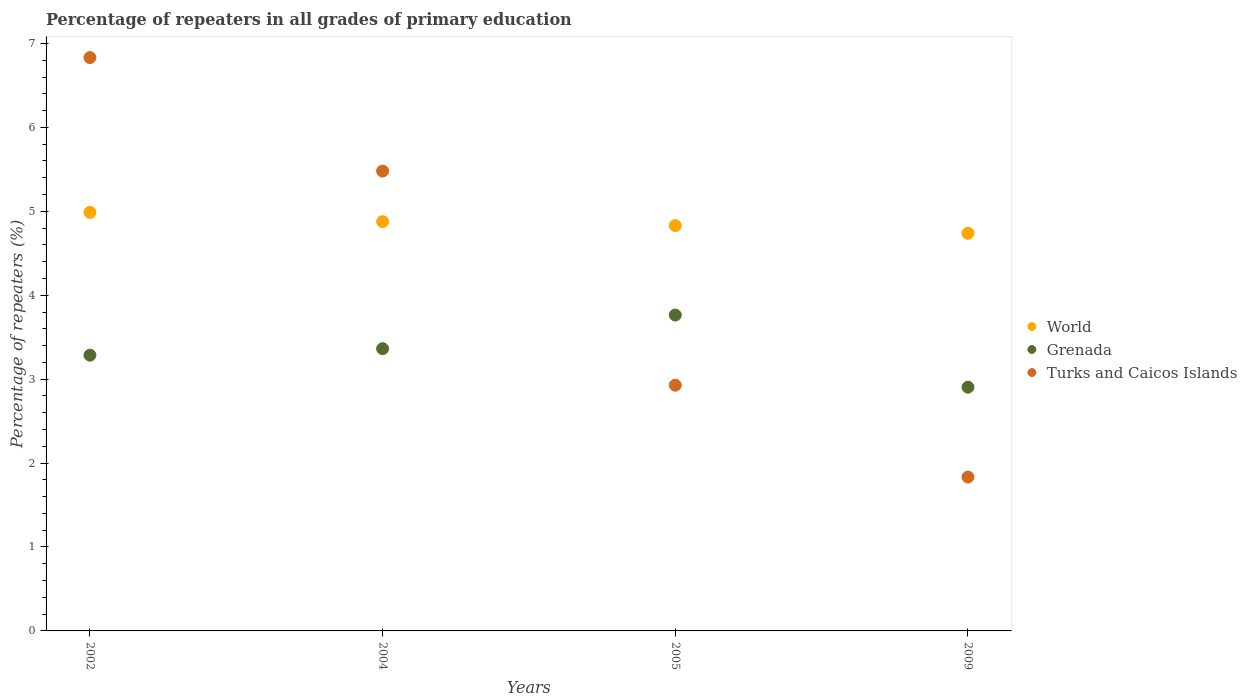What is the percentage of repeaters in World in 2002?
Offer a terse response. 4.99. Across all years, what is the maximum percentage of repeaters in World?
Keep it short and to the point. 4.99. Across all years, what is the minimum percentage of repeaters in World?
Provide a succinct answer. 4.74. In which year was the percentage of repeaters in World minimum?
Keep it short and to the point. 2009. What is the total percentage of repeaters in World in the graph?
Provide a short and direct response. 19.43. What is the difference between the percentage of repeaters in Grenada in 2002 and that in 2009?
Ensure brevity in your answer.  0.38. What is the difference between the percentage of repeaters in Turks and Caicos Islands in 2004 and the percentage of repeaters in World in 2005?
Provide a succinct answer. 0.65. What is the average percentage of repeaters in Turks and Caicos Islands per year?
Your response must be concise. 4.27. In the year 2009, what is the difference between the percentage of repeaters in Turks and Caicos Islands and percentage of repeaters in Grenada?
Provide a short and direct response. -1.07. What is the ratio of the percentage of repeaters in Turks and Caicos Islands in 2002 to that in 2009?
Provide a succinct answer. 3.73. What is the difference between the highest and the second highest percentage of repeaters in Turks and Caicos Islands?
Provide a short and direct response. 1.35. What is the difference between the highest and the lowest percentage of repeaters in Grenada?
Provide a short and direct response. 0.86. In how many years, is the percentage of repeaters in Turks and Caicos Islands greater than the average percentage of repeaters in Turks and Caicos Islands taken over all years?
Keep it short and to the point. 2. Is it the case that in every year, the sum of the percentage of repeaters in World and percentage of repeaters in Turks and Caicos Islands  is greater than the percentage of repeaters in Grenada?
Offer a very short reply. Yes. Does the percentage of repeaters in Turks and Caicos Islands monotonically increase over the years?
Ensure brevity in your answer.  No. Is the percentage of repeaters in Turks and Caicos Islands strictly less than the percentage of repeaters in World over the years?
Give a very brief answer. No. How many dotlines are there?
Your answer should be compact. 3. How many years are there in the graph?
Your answer should be compact. 4. Does the graph contain grids?
Make the answer very short. No. Where does the legend appear in the graph?
Your answer should be very brief. Center right. How are the legend labels stacked?
Offer a very short reply. Vertical. What is the title of the graph?
Provide a short and direct response. Percentage of repeaters in all grades of primary education. What is the label or title of the X-axis?
Provide a succinct answer. Years. What is the label or title of the Y-axis?
Ensure brevity in your answer.  Percentage of repeaters (%). What is the Percentage of repeaters (%) of World in 2002?
Provide a succinct answer. 4.99. What is the Percentage of repeaters (%) in Grenada in 2002?
Ensure brevity in your answer.  3.29. What is the Percentage of repeaters (%) of Turks and Caicos Islands in 2002?
Provide a short and direct response. 6.83. What is the Percentage of repeaters (%) of World in 2004?
Make the answer very short. 4.88. What is the Percentage of repeaters (%) in Grenada in 2004?
Provide a succinct answer. 3.36. What is the Percentage of repeaters (%) of Turks and Caicos Islands in 2004?
Offer a very short reply. 5.48. What is the Percentage of repeaters (%) in World in 2005?
Offer a very short reply. 4.83. What is the Percentage of repeaters (%) of Grenada in 2005?
Your answer should be very brief. 3.76. What is the Percentage of repeaters (%) in Turks and Caicos Islands in 2005?
Ensure brevity in your answer.  2.93. What is the Percentage of repeaters (%) in World in 2009?
Your answer should be compact. 4.74. What is the Percentage of repeaters (%) in Grenada in 2009?
Offer a very short reply. 2.9. What is the Percentage of repeaters (%) in Turks and Caicos Islands in 2009?
Your answer should be very brief. 1.83. Across all years, what is the maximum Percentage of repeaters (%) of World?
Give a very brief answer. 4.99. Across all years, what is the maximum Percentage of repeaters (%) in Grenada?
Make the answer very short. 3.76. Across all years, what is the maximum Percentage of repeaters (%) in Turks and Caicos Islands?
Your answer should be very brief. 6.83. Across all years, what is the minimum Percentage of repeaters (%) in World?
Your response must be concise. 4.74. Across all years, what is the minimum Percentage of repeaters (%) in Grenada?
Your answer should be compact. 2.9. Across all years, what is the minimum Percentage of repeaters (%) in Turks and Caicos Islands?
Offer a very short reply. 1.83. What is the total Percentage of repeaters (%) in World in the graph?
Your answer should be compact. 19.43. What is the total Percentage of repeaters (%) of Grenada in the graph?
Keep it short and to the point. 13.32. What is the total Percentage of repeaters (%) in Turks and Caicos Islands in the graph?
Provide a succinct answer. 17.07. What is the difference between the Percentage of repeaters (%) in World in 2002 and that in 2004?
Make the answer very short. 0.11. What is the difference between the Percentage of repeaters (%) in Grenada in 2002 and that in 2004?
Provide a succinct answer. -0.08. What is the difference between the Percentage of repeaters (%) of Turks and Caicos Islands in 2002 and that in 2004?
Keep it short and to the point. 1.35. What is the difference between the Percentage of repeaters (%) of World in 2002 and that in 2005?
Offer a very short reply. 0.16. What is the difference between the Percentage of repeaters (%) in Grenada in 2002 and that in 2005?
Your answer should be very brief. -0.48. What is the difference between the Percentage of repeaters (%) in Turks and Caicos Islands in 2002 and that in 2005?
Provide a short and direct response. 3.9. What is the difference between the Percentage of repeaters (%) in World in 2002 and that in 2009?
Your answer should be compact. 0.25. What is the difference between the Percentage of repeaters (%) in Grenada in 2002 and that in 2009?
Offer a very short reply. 0.38. What is the difference between the Percentage of repeaters (%) in Turks and Caicos Islands in 2002 and that in 2009?
Give a very brief answer. 5. What is the difference between the Percentage of repeaters (%) of World in 2004 and that in 2005?
Provide a succinct answer. 0.05. What is the difference between the Percentage of repeaters (%) in Grenada in 2004 and that in 2005?
Give a very brief answer. -0.4. What is the difference between the Percentage of repeaters (%) in Turks and Caicos Islands in 2004 and that in 2005?
Offer a very short reply. 2.55. What is the difference between the Percentage of repeaters (%) of World in 2004 and that in 2009?
Offer a terse response. 0.14. What is the difference between the Percentage of repeaters (%) in Grenada in 2004 and that in 2009?
Your response must be concise. 0.46. What is the difference between the Percentage of repeaters (%) of Turks and Caicos Islands in 2004 and that in 2009?
Provide a short and direct response. 3.65. What is the difference between the Percentage of repeaters (%) of World in 2005 and that in 2009?
Provide a short and direct response. 0.09. What is the difference between the Percentage of repeaters (%) in Grenada in 2005 and that in 2009?
Your answer should be very brief. 0.86. What is the difference between the Percentage of repeaters (%) in Turks and Caicos Islands in 2005 and that in 2009?
Ensure brevity in your answer.  1.09. What is the difference between the Percentage of repeaters (%) in World in 2002 and the Percentage of repeaters (%) in Grenada in 2004?
Provide a succinct answer. 1.62. What is the difference between the Percentage of repeaters (%) in World in 2002 and the Percentage of repeaters (%) in Turks and Caicos Islands in 2004?
Ensure brevity in your answer.  -0.49. What is the difference between the Percentage of repeaters (%) in Grenada in 2002 and the Percentage of repeaters (%) in Turks and Caicos Islands in 2004?
Provide a short and direct response. -2.19. What is the difference between the Percentage of repeaters (%) in World in 2002 and the Percentage of repeaters (%) in Grenada in 2005?
Your answer should be compact. 1.22. What is the difference between the Percentage of repeaters (%) of World in 2002 and the Percentage of repeaters (%) of Turks and Caicos Islands in 2005?
Your answer should be very brief. 2.06. What is the difference between the Percentage of repeaters (%) in Grenada in 2002 and the Percentage of repeaters (%) in Turks and Caicos Islands in 2005?
Your answer should be compact. 0.36. What is the difference between the Percentage of repeaters (%) in World in 2002 and the Percentage of repeaters (%) in Grenada in 2009?
Keep it short and to the point. 2.08. What is the difference between the Percentage of repeaters (%) in World in 2002 and the Percentage of repeaters (%) in Turks and Caicos Islands in 2009?
Give a very brief answer. 3.15. What is the difference between the Percentage of repeaters (%) in Grenada in 2002 and the Percentage of repeaters (%) in Turks and Caicos Islands in 2009?
Your answer should be very brief. 1.45. What is the difference between the Percentage of repeaters (%) of World in 2004 and the Percentage of repeaters (%) of Grenada in 2005?
Your answer should be compact. 1.11. What is the difference between the Percentage of repeaters (%) in World in 2004 and the Percentage of repeaters (%) in Turks and Caicos Islands in 2005?
Provide a succinct answer. 1.95. What is the difference between the Percentage of repeaters (%) in Grenada in 2004 and the Percentage of repeaters (%) in Turks and Caicos Islands in 2005?
Offer a terse response. 0.44. What is the difference between the Percentage of repeaters (%) of World in 2004 and the Percentage of repeaters (%) of Grenada in 2009?
Provide a succinct answer. 1.97. What is the difference between the Percentage of repeaters (%) of World in 2004 and the Percentage of repeaters (%) of Turks and Caicos Islands in 2009?
Offer a very short reply. 3.04. What is the difference between the Percentage of repeaters (%) of Grenada in 2004 and the Percentage of repeaters (%) of Turks and Caicos Islands in 2009?
Provide a succinct answer. 1.53. What is the difference between the Percentage of repeaters (%) in World in 2005 and the Percentage of repeaters (%) in Grenada in 2009?
Give a very brief answer. 1.93. What is the difference between the Percentage of repeaters (%) of World in 2005 and the Percentage of repeaters (%) of Turks and Caicos Islands in 2009?
Make the answer very short. 3. What is the difference between the Percentage of repeaters (%) of Grenada in 2005 and the Percentage of repeaters (%) of Turks and Caicos Islands in 2009?
Your answer should be compact. 1.93. What is the average Percentage of repeaters (%) of World per year?
Offer a terse response. 4.86. What is the average Percentage of repeaters (%) in Grenada per year?
Your response must be concise. 3.33. What is the average Percentage of repeaters (%) in Turks and Caicos Islands per year?
Keep it short and to the point. 4.27. In the year 2002, what is the difference between the Percentage of repeaters (%) in World and Percentage of repeaters (%) in Grenada?
Offer a terse response. 1.7. In the year 2002, what is the difference between the Percentage of repeaters (%) in World and Percentage of repeaters (%) in Turks and Caicos Islands?
Make the answer very short. -1.84. In the year 2002, what is the difference between the Percentage of repeaters (%) in Grenada and Percentage of repeaters (%) in Turks and Caicos Islands?
Your response must be concise. -3.55. In the year 2004, what is the difference between the Percentage of repeaters (%) of World and Percentage of repeaters (%) of Grenada?
Provide a succinct answer. 1.51. In the year 2004, what is the difference between the Percentage of repeaters (%) in World and Percentage of repeaters (%) in Turks and Caicos Islands?
Your response must be concise. -0.6. In the year 2004, what is the difference between the Percentage of repeaters (%) in Grenada and Percentage of repeaters (%) in Turks and Caicos Islands?
Your response must be concise. -2.12. In the year 2005, what is the difference between the Percentage of repeaters (%) in World and Percentage of repeaters (%) in Grenada?
Ensure brevity in your answer.  1.07. In the year 2005, what is the difference between the Percentage of repeaters (%) in World and Percentage of repeaters (%) in Turks and Caicos Islands?
Ensure brevity in your answer.  1.9. In the year 2005, what is the difference between the Percentage of repeaters (%) of Grenada and Percentage of repeaters (%) of Turks and Caicos Islands?
Offer a very short reply. 0.84. In the year 2009, what is the difference between the Percentage of repeaters (%) in World and Percentage of repeaters (%) in Grenada?
Keep it short and to the point. 1.83. In the year 2009, what is the difference between the Percentage of repeaters (%) of World and Percentage of repeaters (%) of Turks and Caicos Islands?
Give a very brief answer. 2.9. In the year 2009, what is the difference between the Percentage of repeaters (%) of Grenada and Percentage of repeaters (%) of Turks and Caicos Islands?
Offer a very short reply. 1.07. What is the ratio of the Percentage of repeaters (%) in World in 2002 to that in 2004?
Provide a succinct answer. 1.02. What is the ratio of the Percentage of repeaters (%) in Turks and Caicos Islands in 2002 to that in 2004?
Give a very brief answer. 1.25. What is the ratio of the Percentage of repeaters (%) of World in 2002 to that in 2005?
Give a very brief answer. 1.03. What is the ratio of the Percentage of repeaters (%) in Grenada in 2002 to that in 2005?
Your answer should be compact. 0.87. What is the ratio of the Percentage of repeaters (%) of Turks and Caicos Islands in 2002 to that in 2005?
Offer a very short reply. 2.33. What is the ratio of the Percentage of repeaters (%) in World in 2002 to that in 2009?
Keep it short and to the point. 1.05. What is the ratio of the Percentage of repeaters (%) in Grenada in 2002 to that in 2009?
Your response must be concise. 1.13. What is the ratio of the Percentage of repeaters (%) in Turks and Caicos Islands in 2002 to that in 2009?
Make the answer very short. 3.73. What is the ratio of the Percentage of repeaters (%) in World in 2004 to that in 2005?
Keep it short and to the point. 1.01. What is the ratio of the Percentage of repeaters (%) in Grenada in 2004 to that in 2005?
Make the answer very short. 0.89. What is the ratio of the Percentage of repeaters (%) of Turks and Caicos Islands in 2004 to that in 2005?
Keep it short and to the point. 1.87. What is the ratio of the Percentage of repeaters (%) of World in 2004 to that in 2009?
Give a very brief answer. 1.03. What is the ratio of the Percentage of repeaters (%) of Grenada in 2004 to that in 2009?
Provide a short and direct response. 1.16. What is the ratio of the Percentage of repeaters (%) in Turks and Caicos Islands in 2004 to that in 2009?
Offer a terse response. 2.99. What is the ratio of the Percentage of repeaters (%) in World in 2005 to that in 2009?
Make the answer very short. 1.02. What is the ratio of the Percentage of repeaters (%) in Grenada in 2005 to that in 2009?
Your answer should be very brief. 1.3. What is the ratio of the Percentage of repeaters (%) in Turks and Caicos Islands in 2005 to that in 2009?
Your response must be concise. 1.6. What is the difference between the highest and the second highest Percentage of repeaters (%) of World?
Offer a terse response. 0.11. What is the difference between the highest and the second highest Percentage of repeaters (%) in Grenada?
Provide a short and direct response. 0.4. What is the difference between the highest and the second highest Percentage of repeaters (%) of Turks and Caicos Islands?
Ensure brevity in your answer.  1.35. What is the difference between the highest and the lowest Percentage of repeaters (%) of World?
Give a very brief answer. 0.25. What is the difference between the highest and the lowest Percentage of repeaters (%) in Grenada?
Offer a terse response. 0.86. What is the difference between the highest and the lowest Percentage of repeaters (%) in Turks and Caicos Islands?
Provide a short and direct response. 5. 